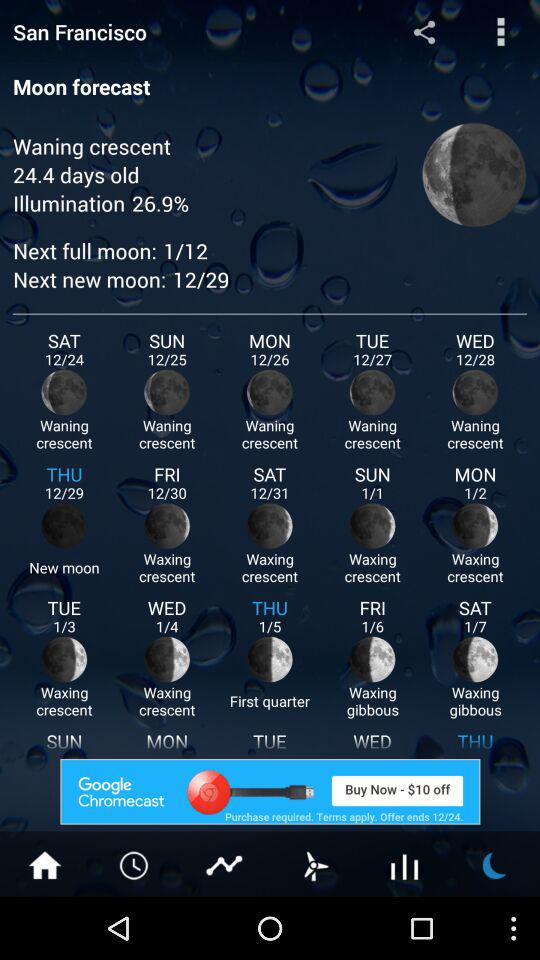What is the next full moon date? The next full moon date is January 12. 